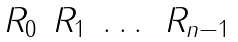<formula> <loc_0><loc_0><loc_500><loc_500>\begin{matrix} R _ { 0 } & R _ { 1 } & \dots & R _ { n - 1 } \end{matrix}</formula> 